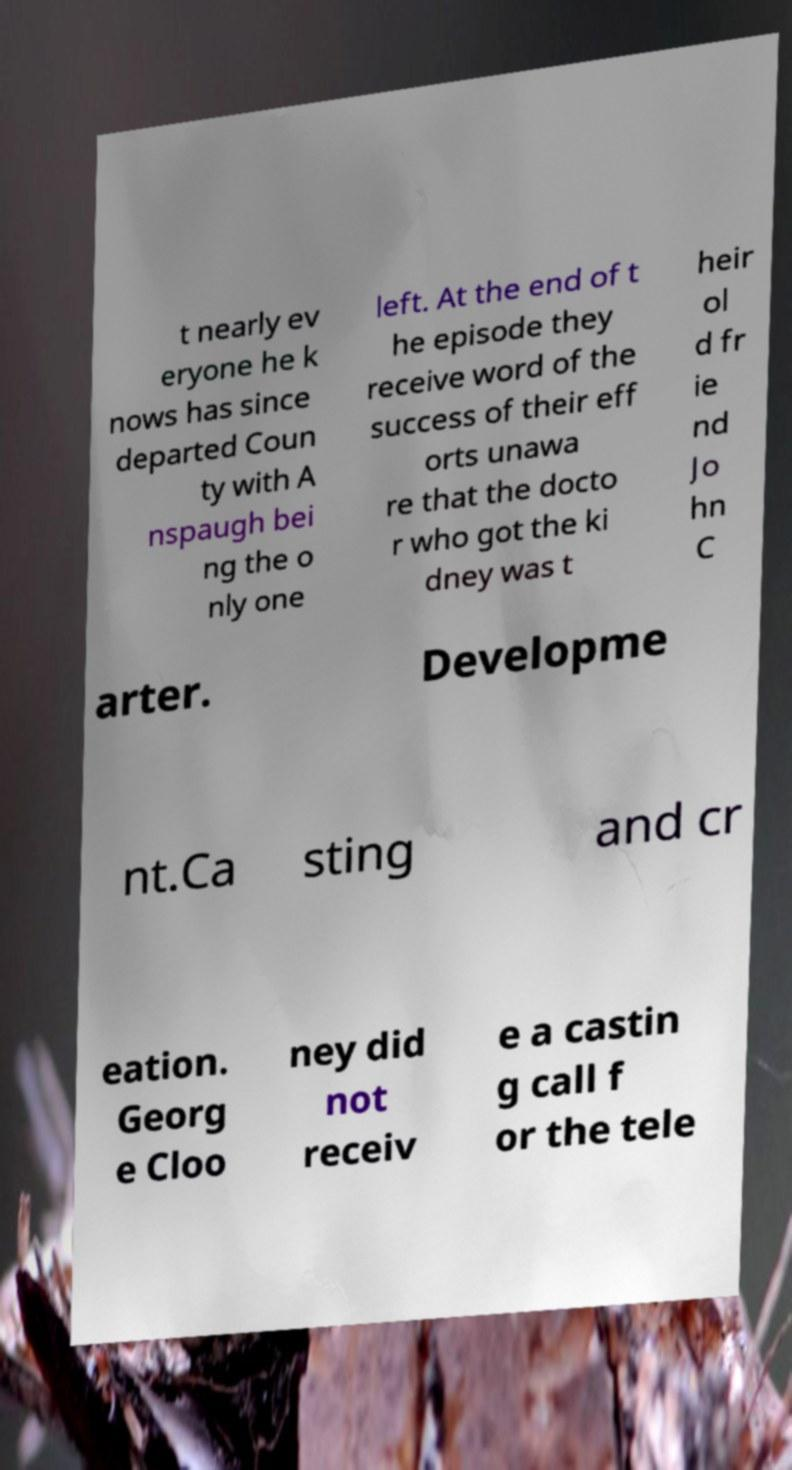For documentation purposes, I need the text within this image transcribed. Could you provide that? t nearly ev eryone he k nows has since departed Coun ty with A nspaugh bei ng the o nly one left. At the end of t he episode they receive word of the success of their eff orts unawa re that the docto r who got the ki dney was t heir ol d fr ie nd Jo hn C arter. Developme nt.Ca sting and cr eation. Georg e Cloo ney did not receiv e a castin g call f or the tele 